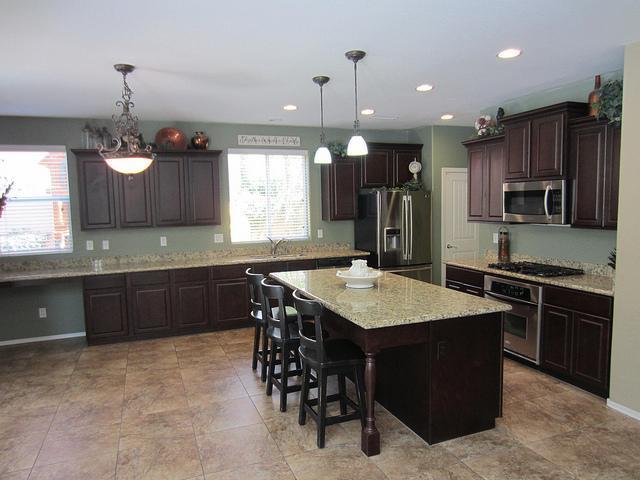How many chairs at the island?
Give a very brief answer. 3. How many hanging lights are there?
Give a very brief answer. 3. How many pots are there?
Give a very brief answer. 0. How many chairs are visible?
Give a very brief answer. 2. 